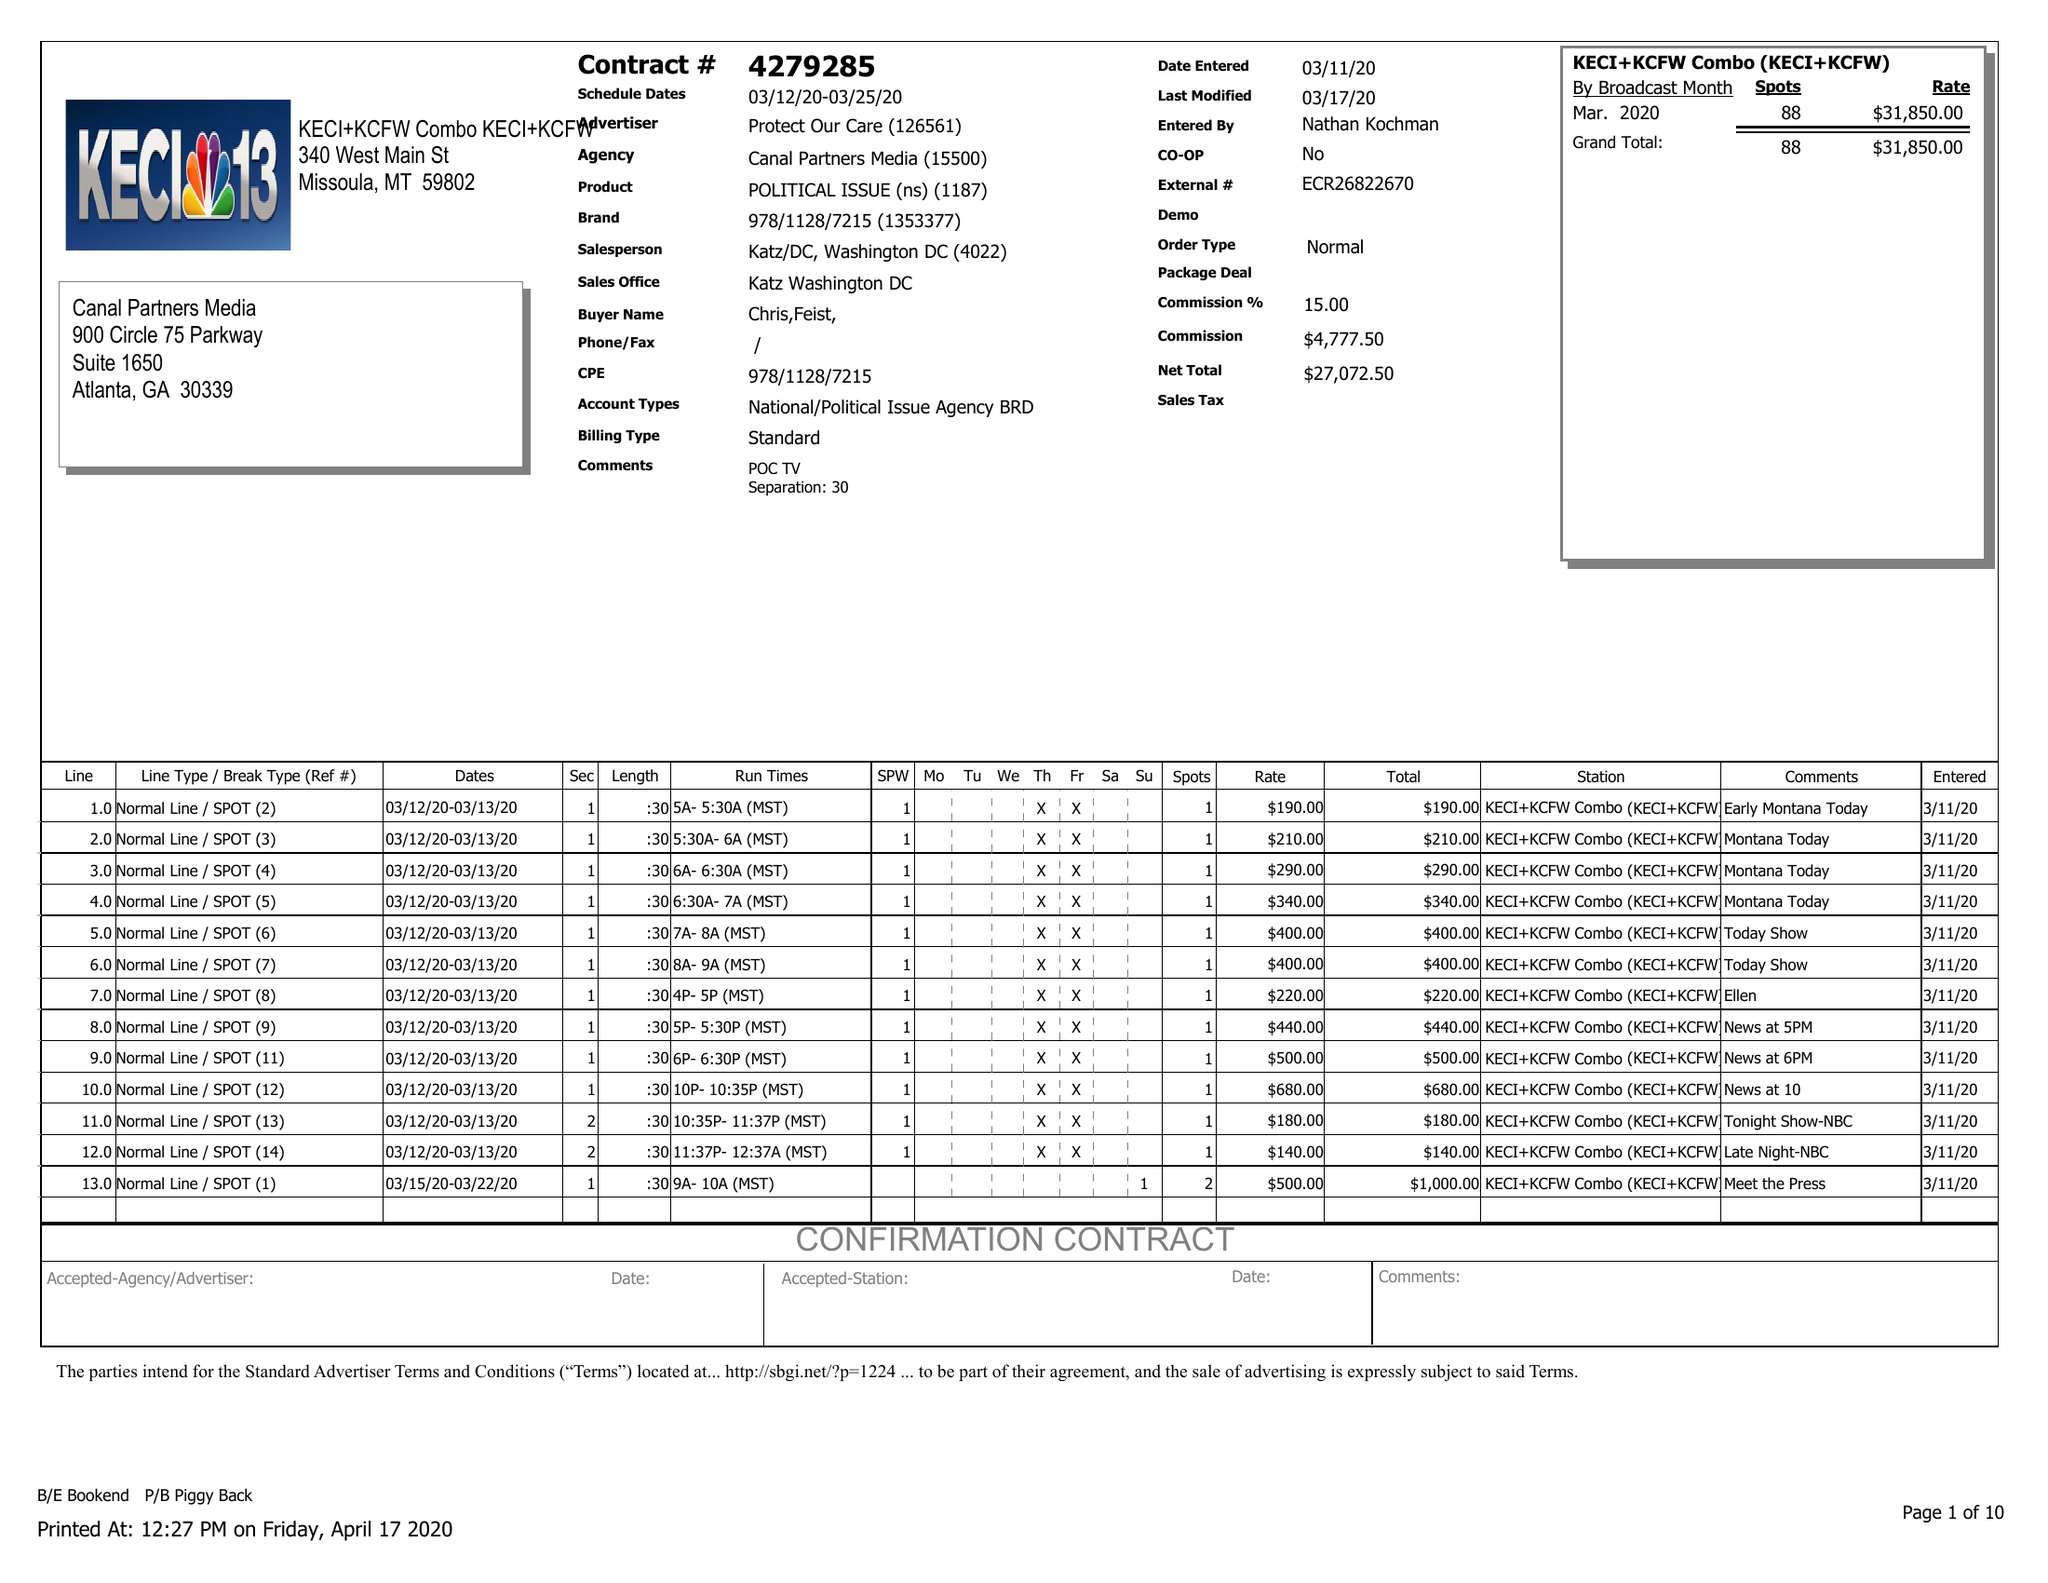What is the value for the advertiser?
Answer the question using a single word or phrase. PROTECT OUR CARE 